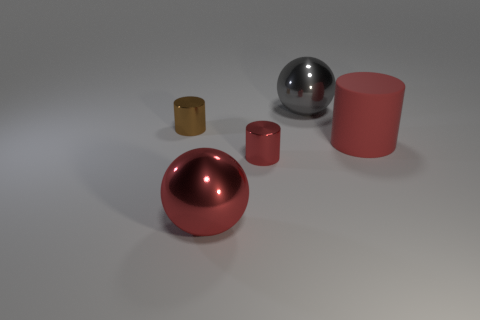There is a large thing that is on the left side of the big gray sphere; does it have the same color as the big matte object?
Make the answer very short. Yes. What is the size of the brown cylinder?
Provide a short and direct response. Small. There is a red object in front of the red cylinder in front of the large rubber object; what is its size?
Your answer should be compact. Large. How many objects have the same color as the rubber cylinder?
Keep it short and to the point. 2. How many large metal things are there?
Offer a terse response. 2. How many tiny red things are the same material as the red sphere?
Your response must be concise. 1. There is another rubber object that is the same shape as the tiny brown object; what is its size?
Keep it short and to the point. Large. What is the brown cylinder made of?
Offer a terse response. Metal. What is the material of the thing right of the shiny sphere behind the small object that is in front of the large red matte cylinder?
Your answer should be very brief. Rubber. Is there any other thing that has the same shape as the big gray thing?
Your response must be concise. Yes. 